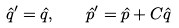<formula> <loc_0><loc_0><loc_500><loc_500>\hat { q } ^ { \prime } = \hat { q } , \quad \hat { p } ^ { \prime } = \hat { p } + C \hat { q }</formula> 